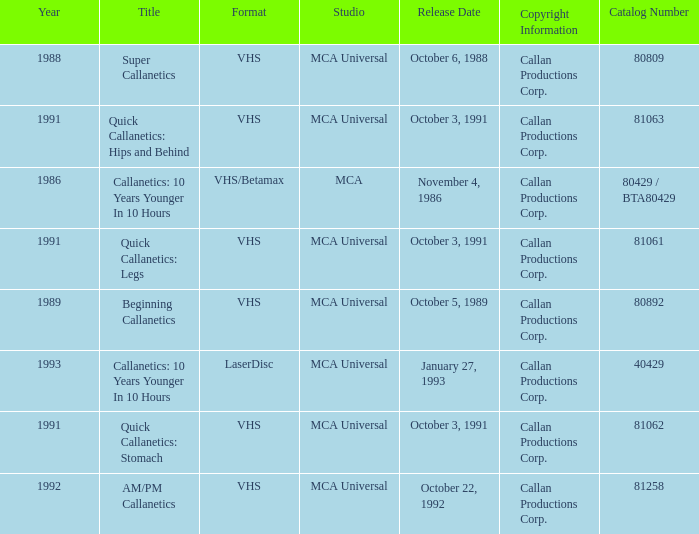Name the catalog number for  october 6, 1988 80809.0. 